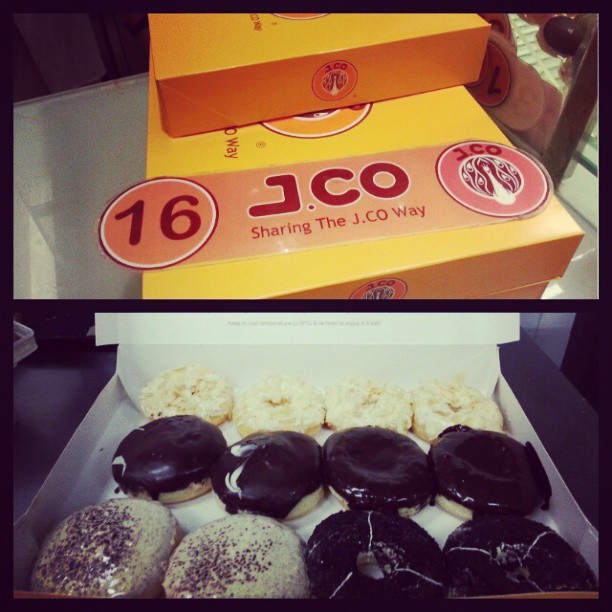Please extract the text content from this image. J.CO 16 Way sHARING THE 1 J.CO J.CO CO J. WAY J.CO 